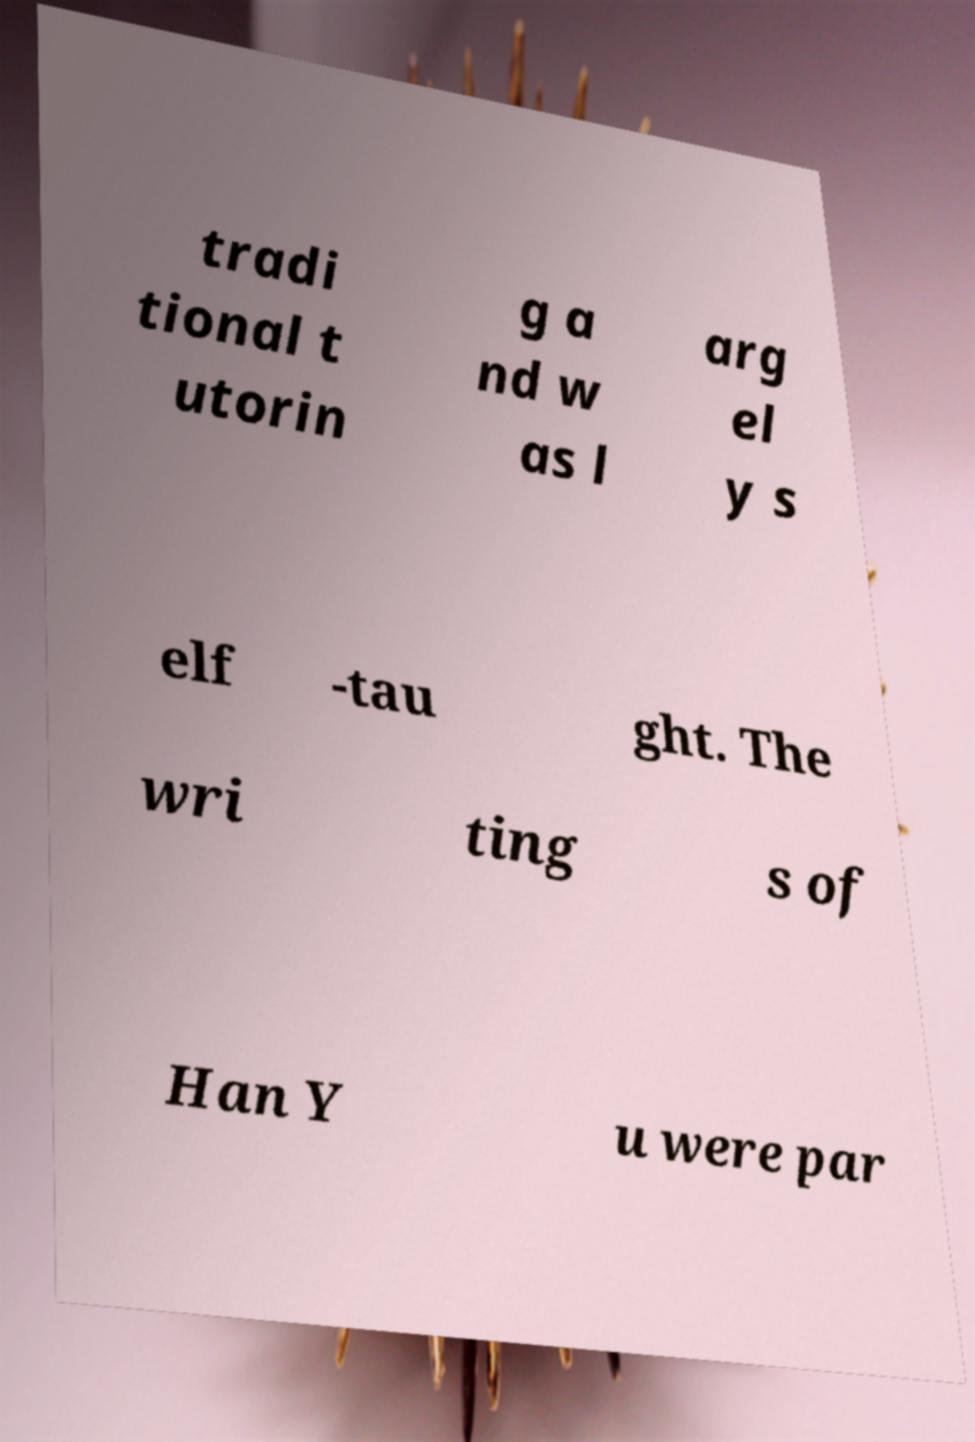Can you read and provide the text displayed in the image?This photo seems to have some interesting text. Can you extract and type it out for me? tradi tional t utorin g a nd w as l arg el y s elf -tau ght. The wri ting s of Han Y u were par 